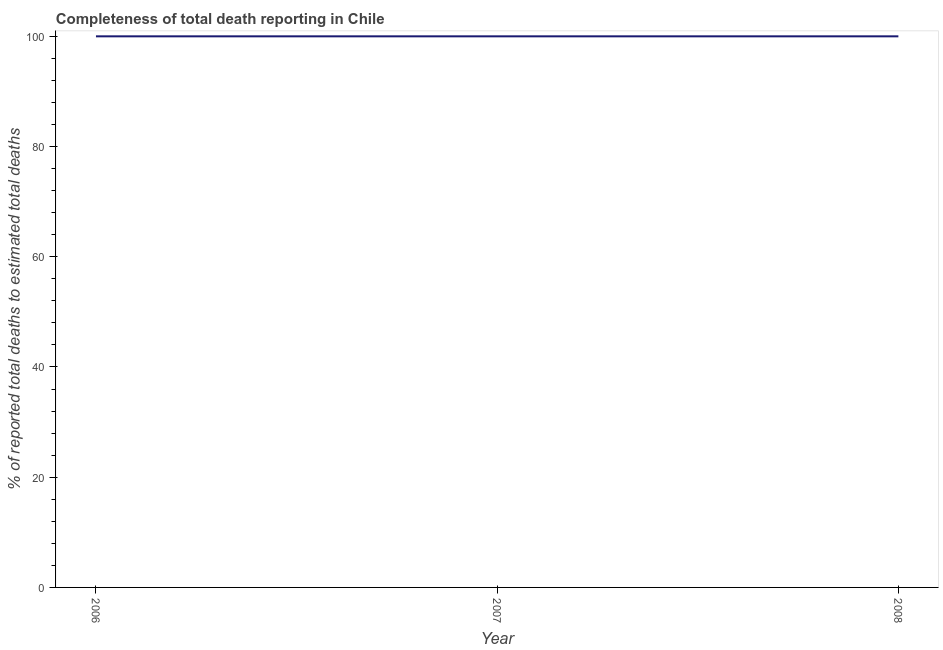What is the completeness of total death reports in 2008?
Your answer should be compact. 100. Across all years, what is the maximum completeness of total death reports?
Your response must be concise. 100. Across all years, what is the minimum completeness of total death reports?
Your answer should be very brief. 100. In which year was the completeness of total death reports minimum?
Make the answer very short. 2006. What is the sum of the completeness of total death reports?
Ensure brevity in your answer.  300. What is the difference between the completeness of total death reports in 2006 and 2007?
Give a very brief answer. 0. Do a majority of the years between 2006 and 2007 (inclusive) have completeness of total death reports greater than 24 %?
Make the answer very short. Yes. Is the completeness of total death reports in 2006 less than that in 2008?
Give a very brief answer. No. What is the difference between the highest and the lowest completeness of total death reports?
Give a very brief answer. 0. Does the completeness of total death reports monotonically increase over the years?
Give a very brief answer. No. How many lines are there?
Ensure brevity in your answer.  1. How many years are there in the graph?
Ensure brevity in your answer.  3. Are the values on the major ticks of Y-axis written in scientific E-notation?
Your answer should be very brief. No. Does the graph contain any zero values?
Your response must be concise. No. What is the title of the graph?
Keep it short and to the point. Completeness of total death reporting in Chile. What is the label or title of the X-axis?
Ensure brevity in your answer.  Year. What is the label or title of the Y-axis?
Provide a succinct answer. % of reported total deaths to estimated total deaths. What is the % of reported total deaths to estimated total deaths of 2006?
Offer a very short reply. 100. What is the difference between the % of reported total deaths to estimated total deaths in 2006 and 2008?
Your response must be concise. 0. What is the difference between the % of reported total deaths to estimated total deaths in 2007 and 2008?
Your response must be concise. 0. What is the ratio of the % of reported total deaths to estimated total deaths in 2006 to that in 2007?
Give a very brief answer. 1. What is the ratio of the % of reported total deaths to estimated total deaths in 2007 to that in 2008?
Offer a terse response. 1. 